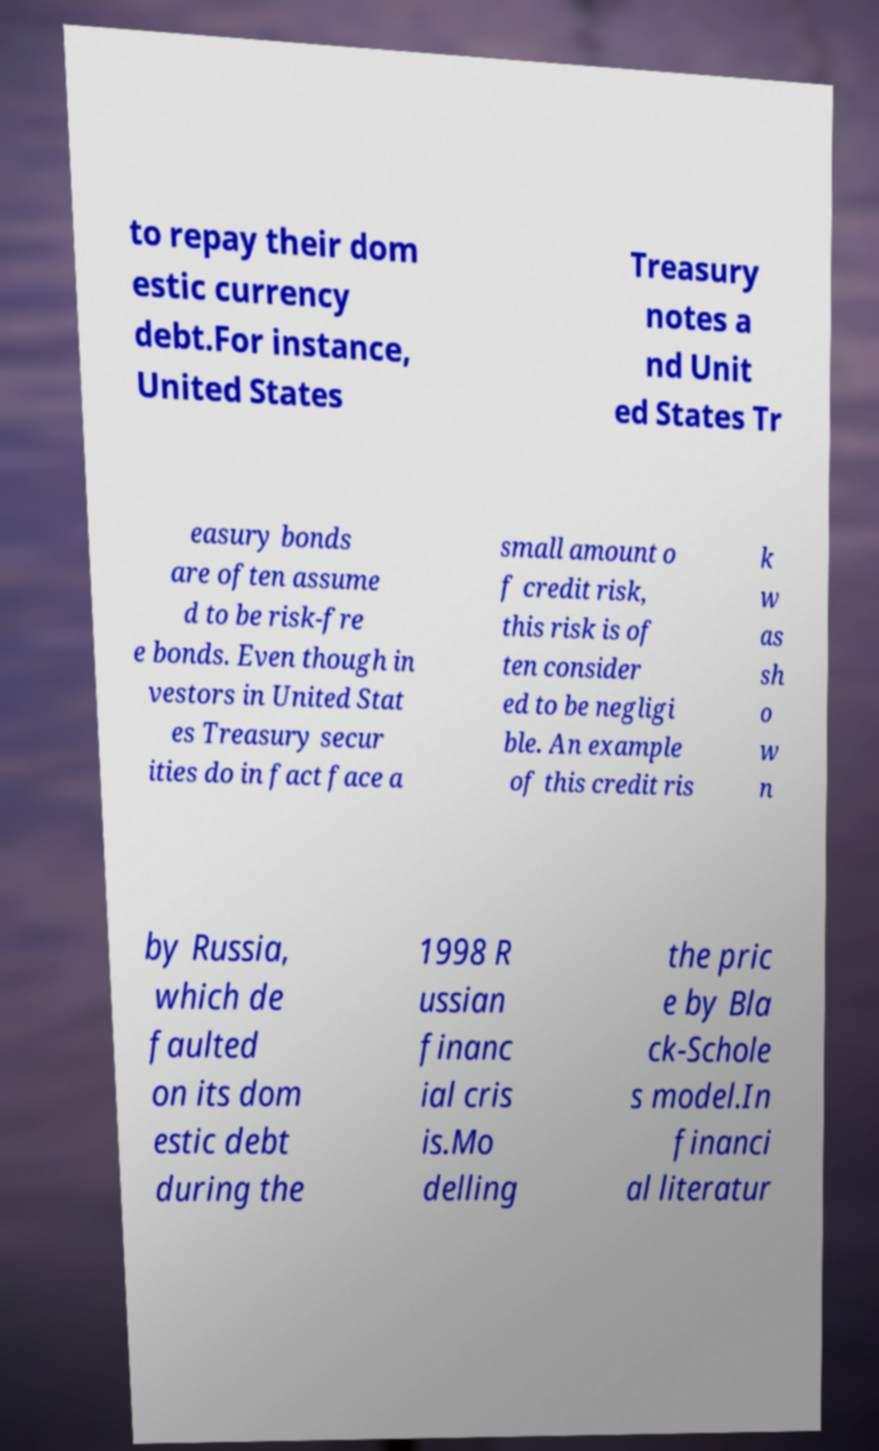Could you assist in decoding the text presented in this image and type it out clearly? to repay their dom estic currency debt.For instance, United States Treasury notes a nd Unit ed States Tr easury bonds are often assume d to be risk-fre e bonds. Even though in vestors in United Stat es Treasury secur ities do in fact face a small amount o f credit risk, this risk is of ten consider ed to be negligi ble. An example of this credit ris k w as sh o w n by Russia, which de faulted on its dom estic debt during the 1998 R ussian financ ial cris is.Mo delling the pric e by Bla ck-Schole s model.In financi al literatur 